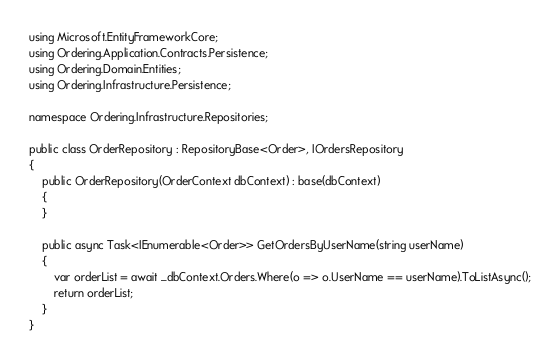Convert code to text. <code><loc_0><loc_0><loc_500><loc_500><_C#_>using Microsoft.EntityFrameworkCore;
using Ordering.Application.Contracts.Persistence;
using Ordering.Domain.Entities;
using Ordering.Infrastructure.Persistence;

namespace Ordering.Infrastructure.Repositories;

public class OrderRepository : RepositoryBase<Order>, IOrdersRepository
{
    public OrderRepository(OrderContext dbContext) : base(dbContext)
    {
    }

    public async Task<IEnumerable<Order>> GetOrdersByUserName(string userName)
    {
        var orderList = await _dbContext.Orders.Where(o => o.UserName == userName).ToListAsync();
        return orderList;
    }
}</code> 